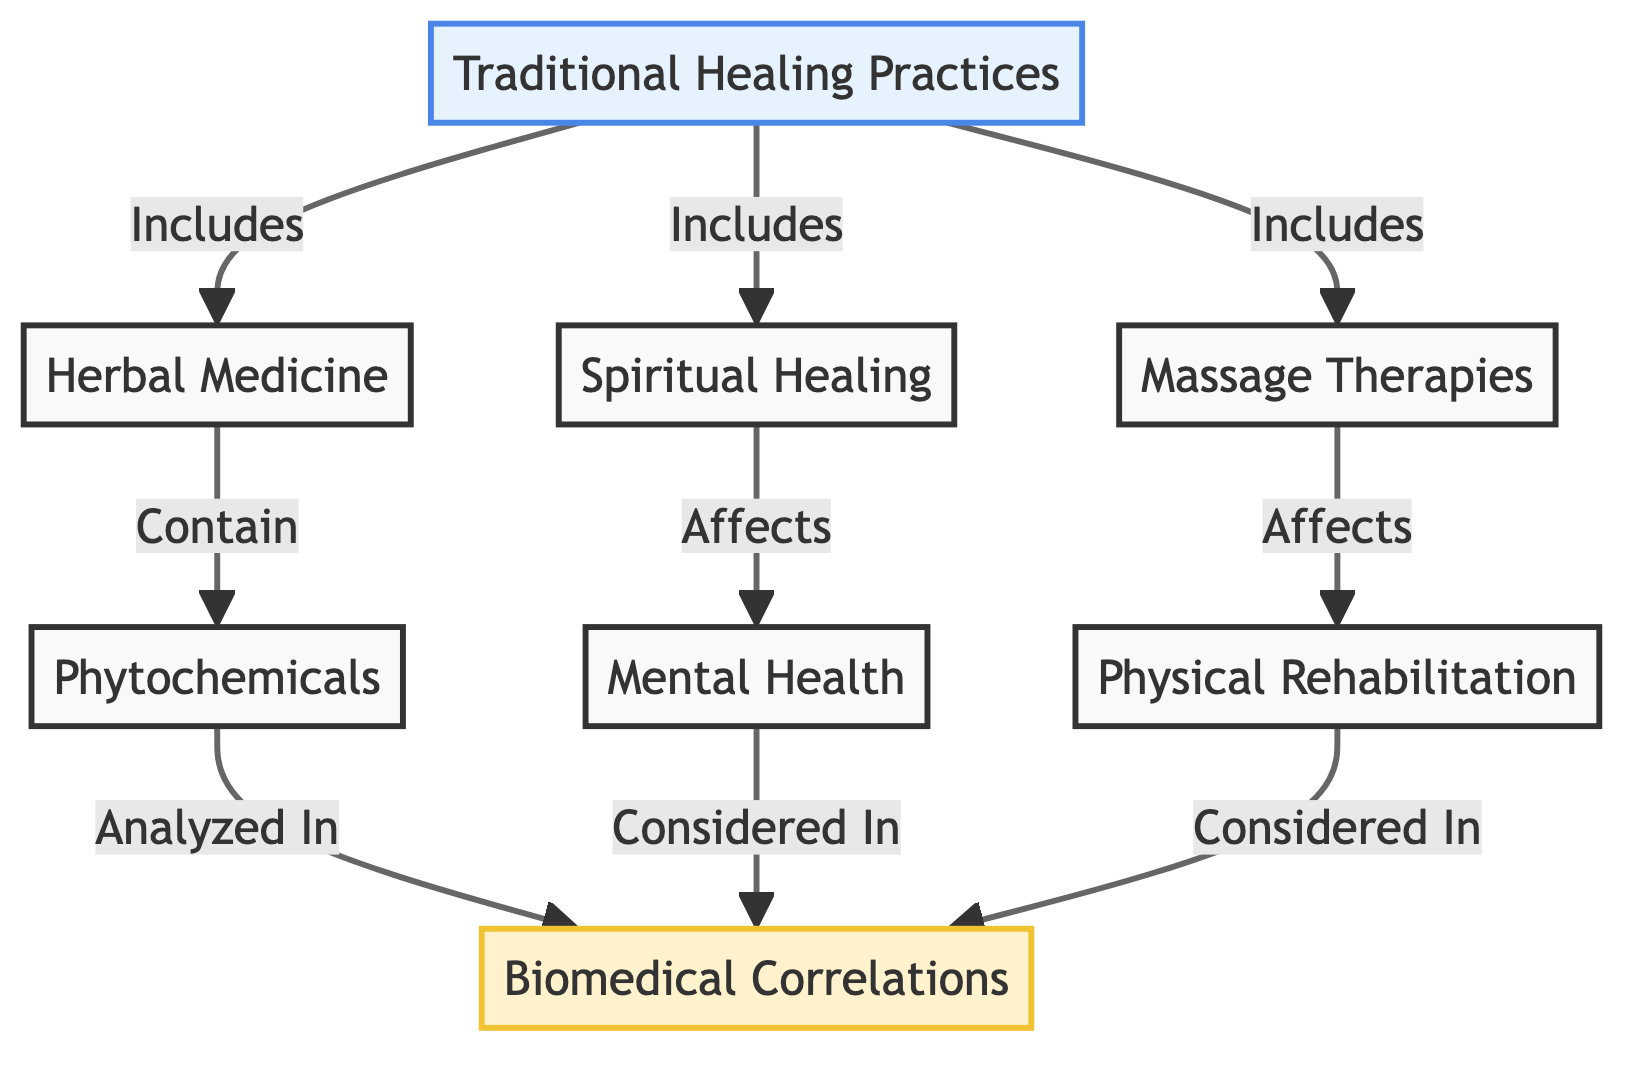What traditional healing practices are included? The diagram indicates that the traditional healing practices include herbal medicine, spiritual healing, and massage therapies, which are directly connected to the main node labeled "Traditional Healing Practices."
Answer: herbal medicine, spiritual healing, massage therapies How many common categories of healing practices are shown? By counting the nodes connected to "Traditional Healing Practices," we see there are three categories: herbal medicine, spiritual healing, and massage therapies.
Answer: 3 What is the biomedical correlation for herbal medicine? The flow from "Herbal Medicine" shows it contains phytochemicals, which in turn are analyzed in the "Biomedical Correlations" node. This demonstrates the link related to herbal medicine.
Answer: phytochemicals Which traditional healing practice affects mental health? The node "Spiritual Healing" is connected by an arrow labeled "Affects" to "Mental Health," indicating its direct influence on this biomedical aspect.
Answer: Spiritual Healing What are the three branches from the traditional healing practices? The branches stemming from "Traditional Healing Practices" are herbal medicine, spiritual healing, and massage therapies. This provides insight into the specific practices under traditional healing.
Answer: herbal medicine, spiritual healing, massage therapies Which traditional healing practice correlates with physical rehabilitation? The diagram shows that "Massage Therapies" affects "Physical Rehabilitation." Hence, it directly links to this biomedical correlation with an arrow.
Answer: Massage Therapies How are phytochemicals and mental health related? Phytochemicals are analyzed within the context of biomedical correlations, while mental health is also considered within the same context. Although there's no direct connection, they both fall under "Biomedical Correlations."
Answer: Analyzed and Considered What does the arrow from massage therapies signify? The arrow going from "Massage Therapies" to "Physical Rehabilitation" signifies that massage therapies affect or contribute to the process of physical rehabilitation, demonstrating a clear impact.
Answer: Affects 